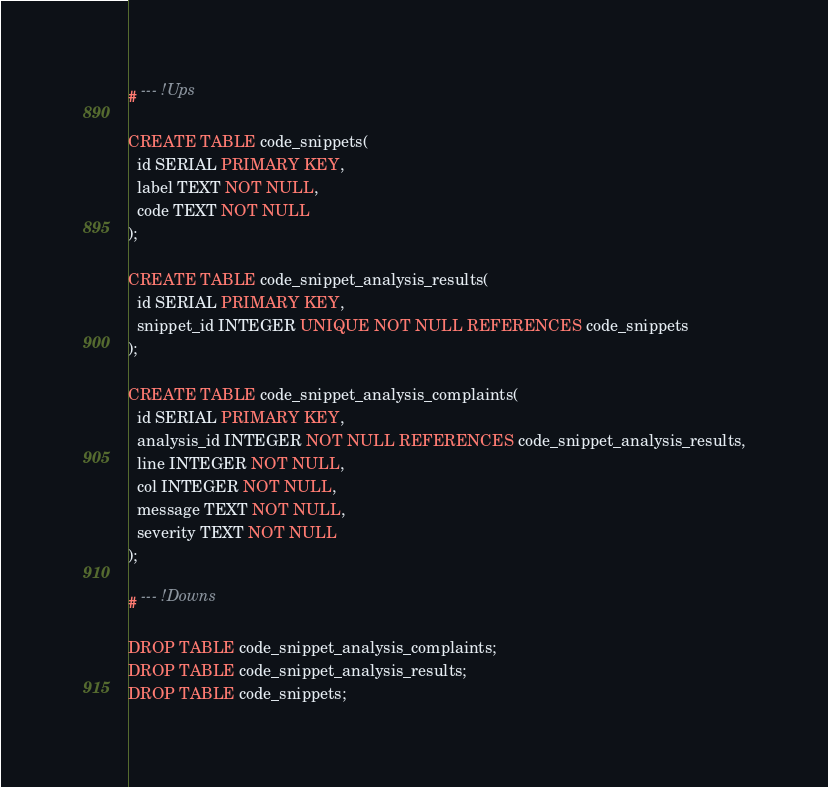<code> <loc_0><loc_0><loc_500><loc_500><_SQL_># --- !Ups

CREATE TABLE code_snippets(
  id SERIAL PRIMARY KEY,
  label TEXT NOT NULL,
  code TEXT NOT NULL
);

CREATE TABLE code_snippet_analysis_results(
  id SERIAL PRIMARY KEY,
  snippet_id INTEGER UNIQUE NOT NULL REFERENCES code_snippets
);

CREATE TABLE code_snippet_analysis_complaints(
  id SERIAL PRIMARY KEY,
  analysis_id INTEGER NOT NULL REFERENCES code_snippet_analysis_results,
  line INTEGER NOT NULL,
  col INTEGER NOT NULL,
  message TEXT NOT NULL,
  severity TEXT NOT NULL
);

# --- !Downs

DROP TABLE code_snippet_analysis_complaints;
DROP TABLE code_snippet_analysis_results;
DROP TABLE code_snippets;
</code> 